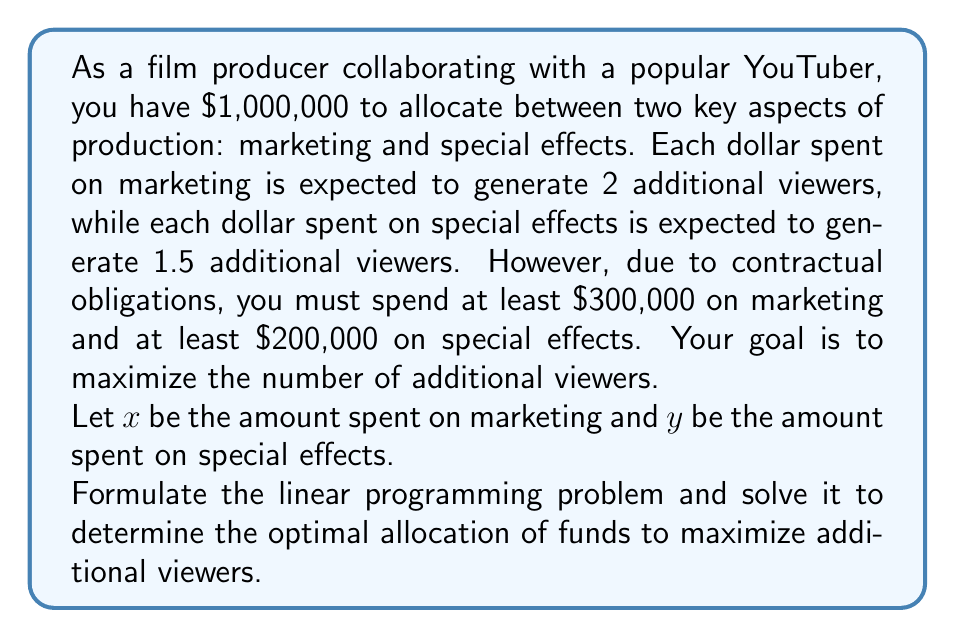Could you help me with this problem? Let's approach this step-by-step:

1) First, we need to formulate the objective function. We want to maximize the number of additional viewers:
   
   Maximize: $Z = 2x + 1.5y$

2) Now, let's list the constraints:
   
   Budget constraint: $x + y \leq 1,000,000$
   Minimum marketing spend: $x \geq 300,000$
   Minimum special effects spend: $y \geq 200,000$
   Non-negativity: $x, y \geq 0$

3) Our linear programming problem is now:

   Maximize: $Z = 2x + 1.5y$
   Subject to:
   $x + y \leq 1,000,000$
   $x \geq 300,000$
   $y \geq 200,000$
   $x, y \geq 0$

4) To solve this, we can use the corner point method. The feasible region is a polygon defined by these constraints. The optimal solution will be at one of the corners of this polygon.

5) The corners of our feasible region are:
   (300000, 200000), (300000, 700000), (800000, 200000)

6) Let's evaluate the objective function at each point:
   
   At (300000, 200000): $Z = 2(300000) + 1.5(200000) = 900000$
   At (300000, 700000): $Z = 2(300000) + 1.5(700000) = 1650000$
   At (800000, 200000): $Z = 2(800000) + 1.5(200000) = 1900000$

7) The maximum value occurs at (800000, 200000), so this is our optimal solution.

Thus, the optimal allocation is to spend $800,000 on marketing and $200,000 on special effects, which will generate 1,900,000 additional viewers.
Answer: $800,000 on marketing, $200,000 on special effects 